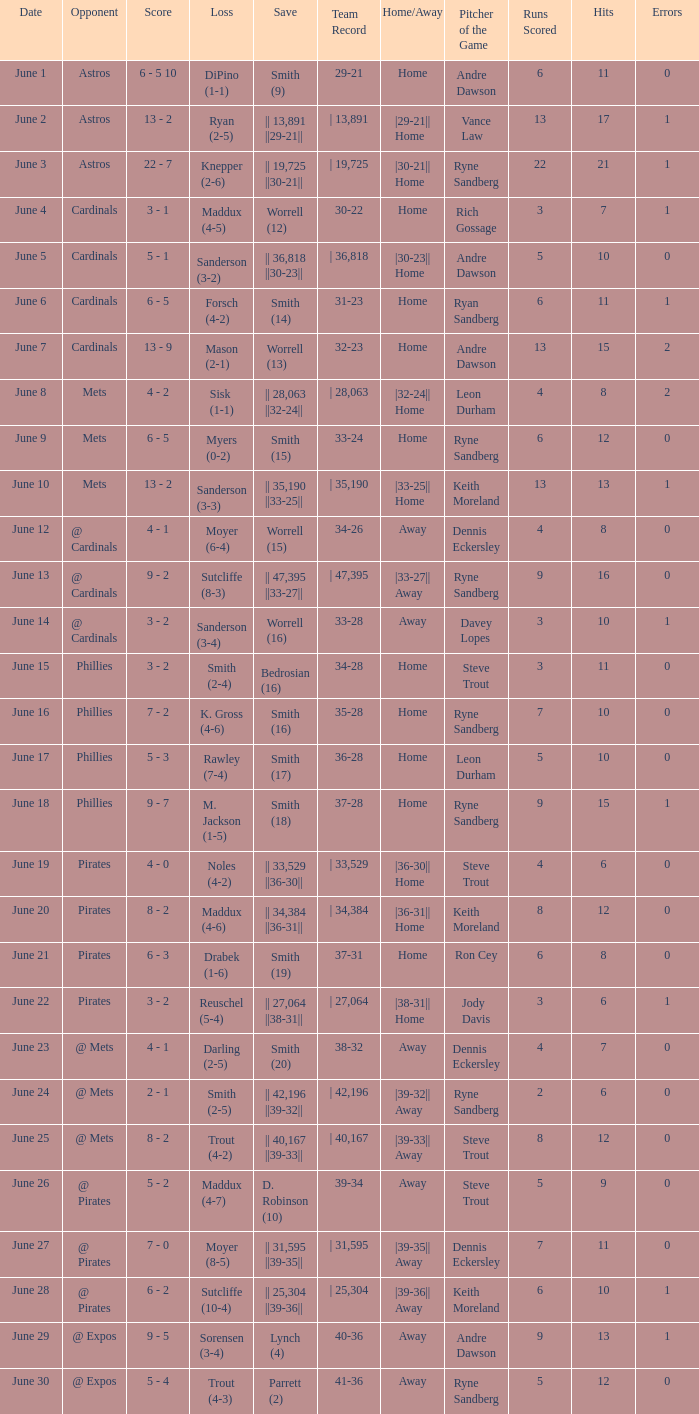The game that has a save of lynch (4) ended with what score? 9 - 5. 